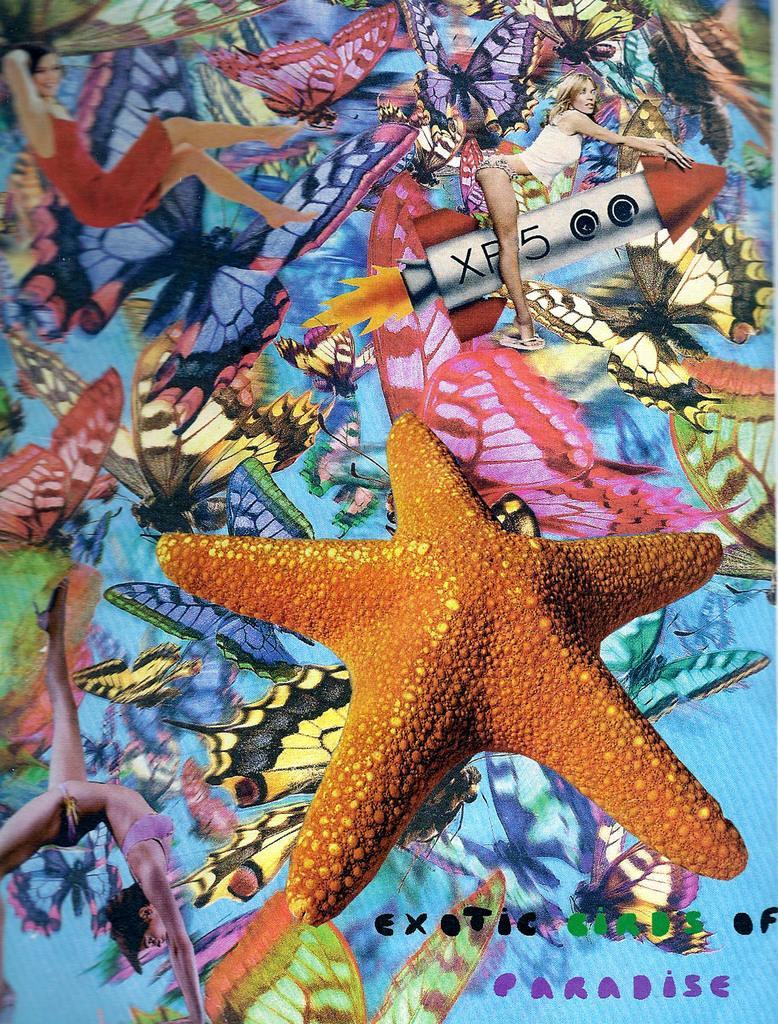In one or two sentences, can you explain what this image depicts? In this image there is a starfish. Behind the starfish there are paintings of different objects and people. There is some text on the right side of the image. 